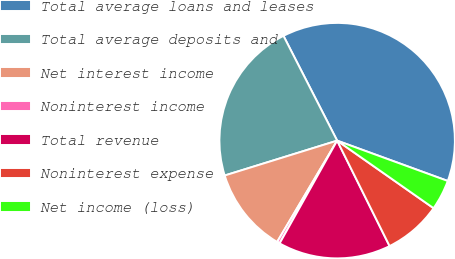Convert chart. <chart><loc_0><loc_0><loc_500><loc_500><pie_chart><fcel>Total average loans and leases<fcel>Total average deposits and<fcel>Net interest income<fcel>Noninterest income<fcel>Total revenue<fcel>Noninterest expense<fcel>Net income (loss)<nl><fcel>38.1%<fcel>22.25%<fcel>11.7%<fcel>0.39%<fcel>15.47%<fcel>7.93%<fcel>4.16%<nl></chart> 